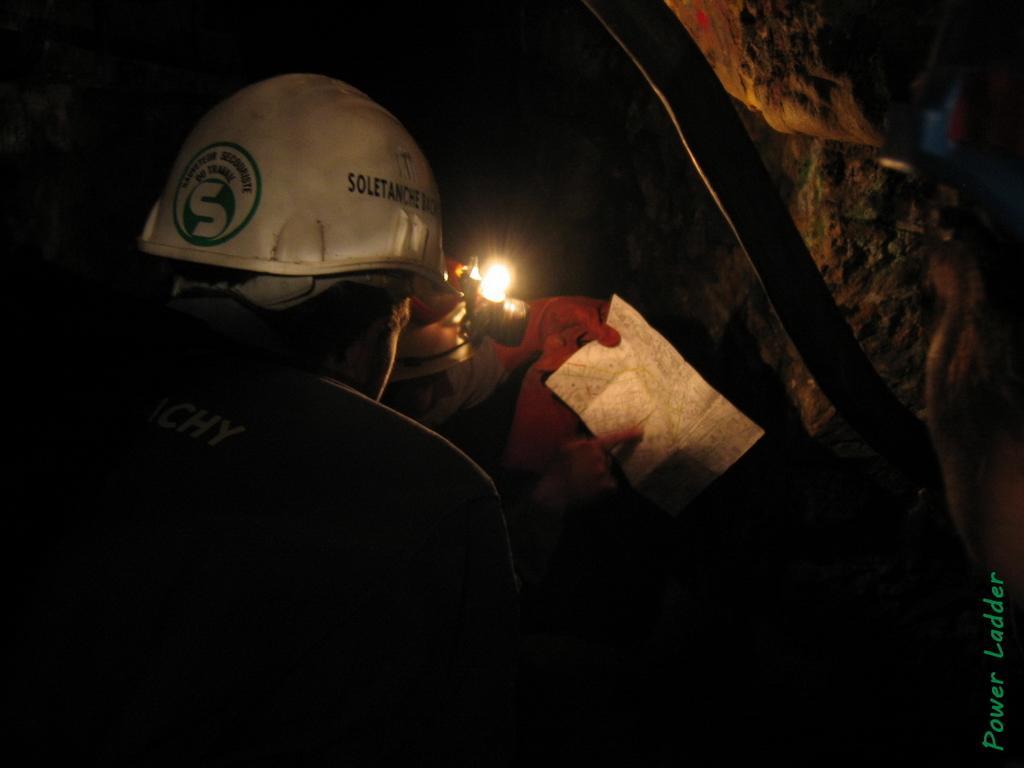How would you summarize this image in a sentence or two? In the picture I can see two men and looks like they are in the cave. There is a man on the left side and there is a helmet on his head. I can see another man and he is holding a piece of paper in his hands. 